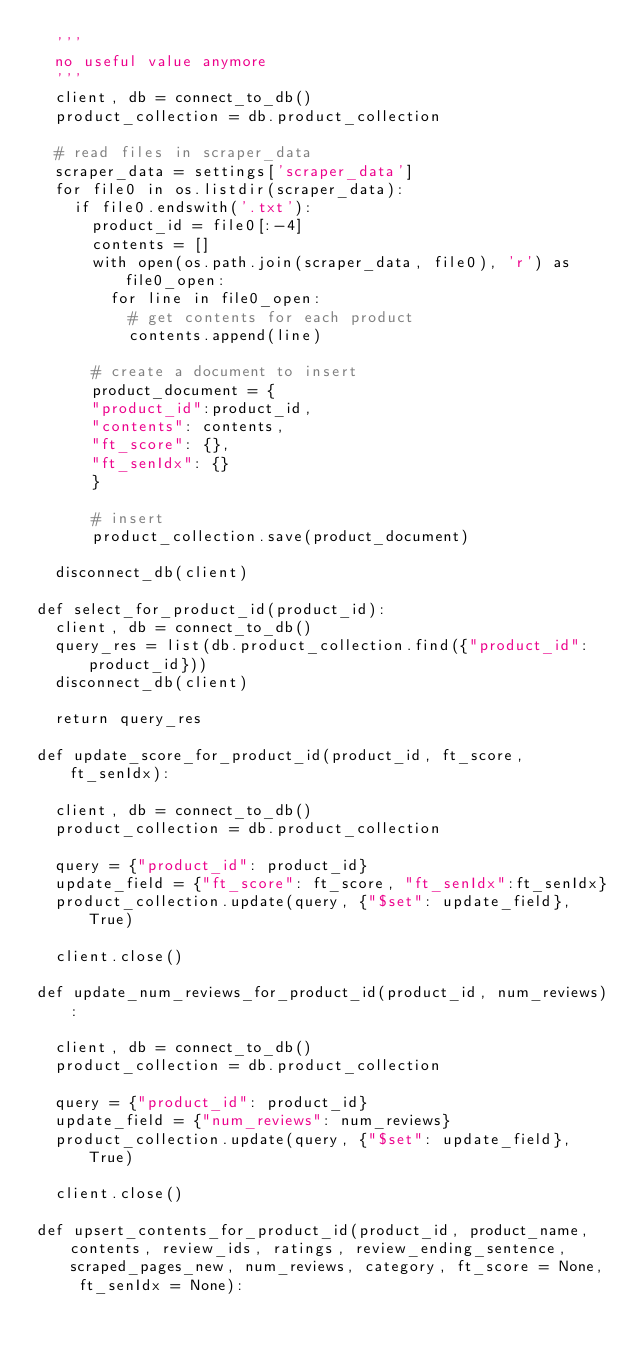<code> <loc_0><loc_0><loc_500><loc_500><_Python_>	'''
	no useful value anymore
	'''
	client, db = connect_to_db()
	product_collection = db.product_collection

	# read files in scraper_data
	scraper_data = settings['scraper_data']
	for file0 in os.listdir(scraper_data):
		if file0.endswith('.txt'):
			product_id = file0[:-4]
			contents = []
			with open(os.path.join(scraper_data, file0), 'r') as file0_open:
				for line in file0_open:
					# get contents for each product
					contents.append(line)

			# create a document to insert
			product_document = {
			"product_id":product_id,
			"contents": contents,
			"ft_score": {},
			"ft_senIdx": {}
			}
			
			# insert
			product_collection.save(product_document)

	disconnect_db(client)

def select_for_product_id(product_id):
	client, db = connect_to_db()
	query_res = list(db.product_collection.find({"product_id": product_id}))
	disconnect_db(client)

	return query_res

def update_score_for_product_id(product_id, ft_score, ft_senIdx):

	client, db = connect_to_db()
	product_collection = db.product_collection

	query = {"product_id": product_id}
	update_field = {"ft_score": ft_score, "ft_senIdx":ft_senIdx}
	product_collection.update(query, {"$set": update_field}, True)

	client.close()

def update_num_reviews_for_product_id(product_id, num_reviews):

	client, db = connect_to_db()
	product_collection = db.product_collection

	query = {"product_id": product_id}
	update_field = {"num_reviews": num_reviews}
	product_collection.update(query, {"$set": update_field}, True)

	client.close()

def upsert_contents_for_product_id(product_id, product_name, contents, review_ids, ratings, review_ending_sentence, scraped_pages_new, num_reviews, category, ft_score = None, ft_senIdx = None):</code> 